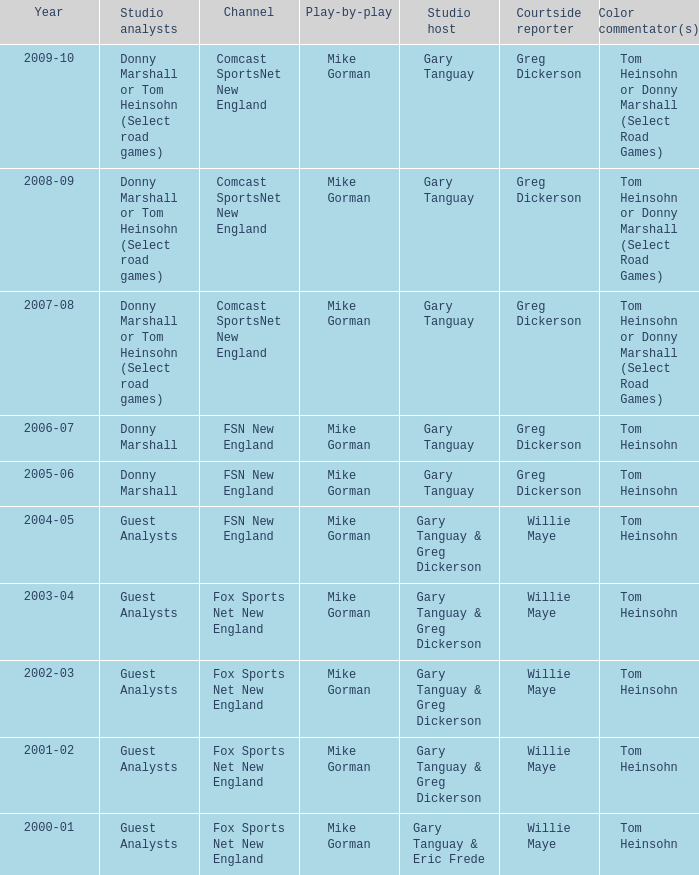Which color commentator owns a channel of fsn new england, and a period of 2004-05? Tom Heinsohn. 